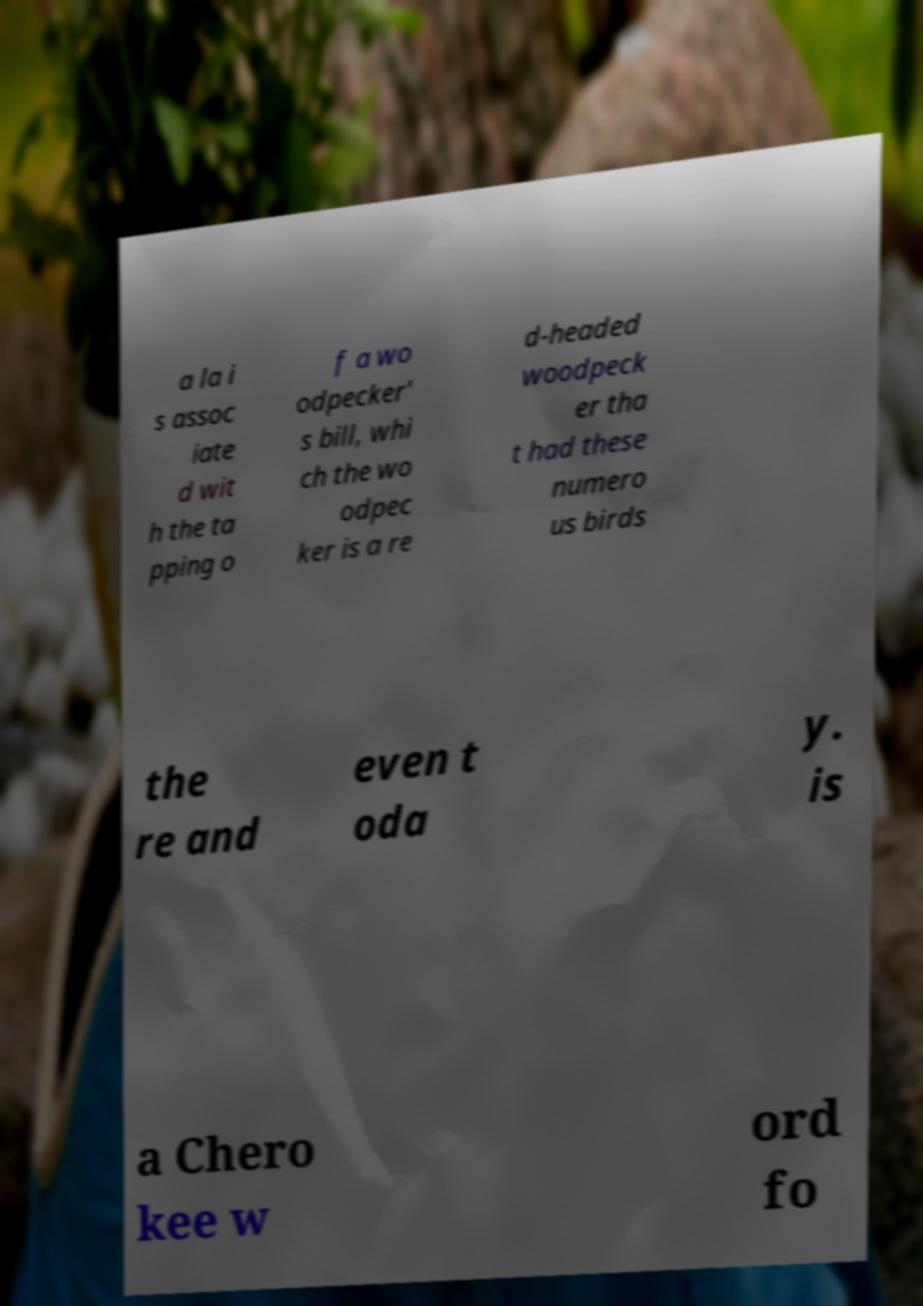Can you read and provide the text displayed in the image?This photo seems to have some interesting text. Can you extract and type it out for me? a la i s assoc iate d wit h the ta pping o f a wo odpecker' s bill, whi ch the wo odpec ker is a re d-headed woodpeck er tha t had these numero us birds the re and even t oda y. is a Chero kee w ord fo 